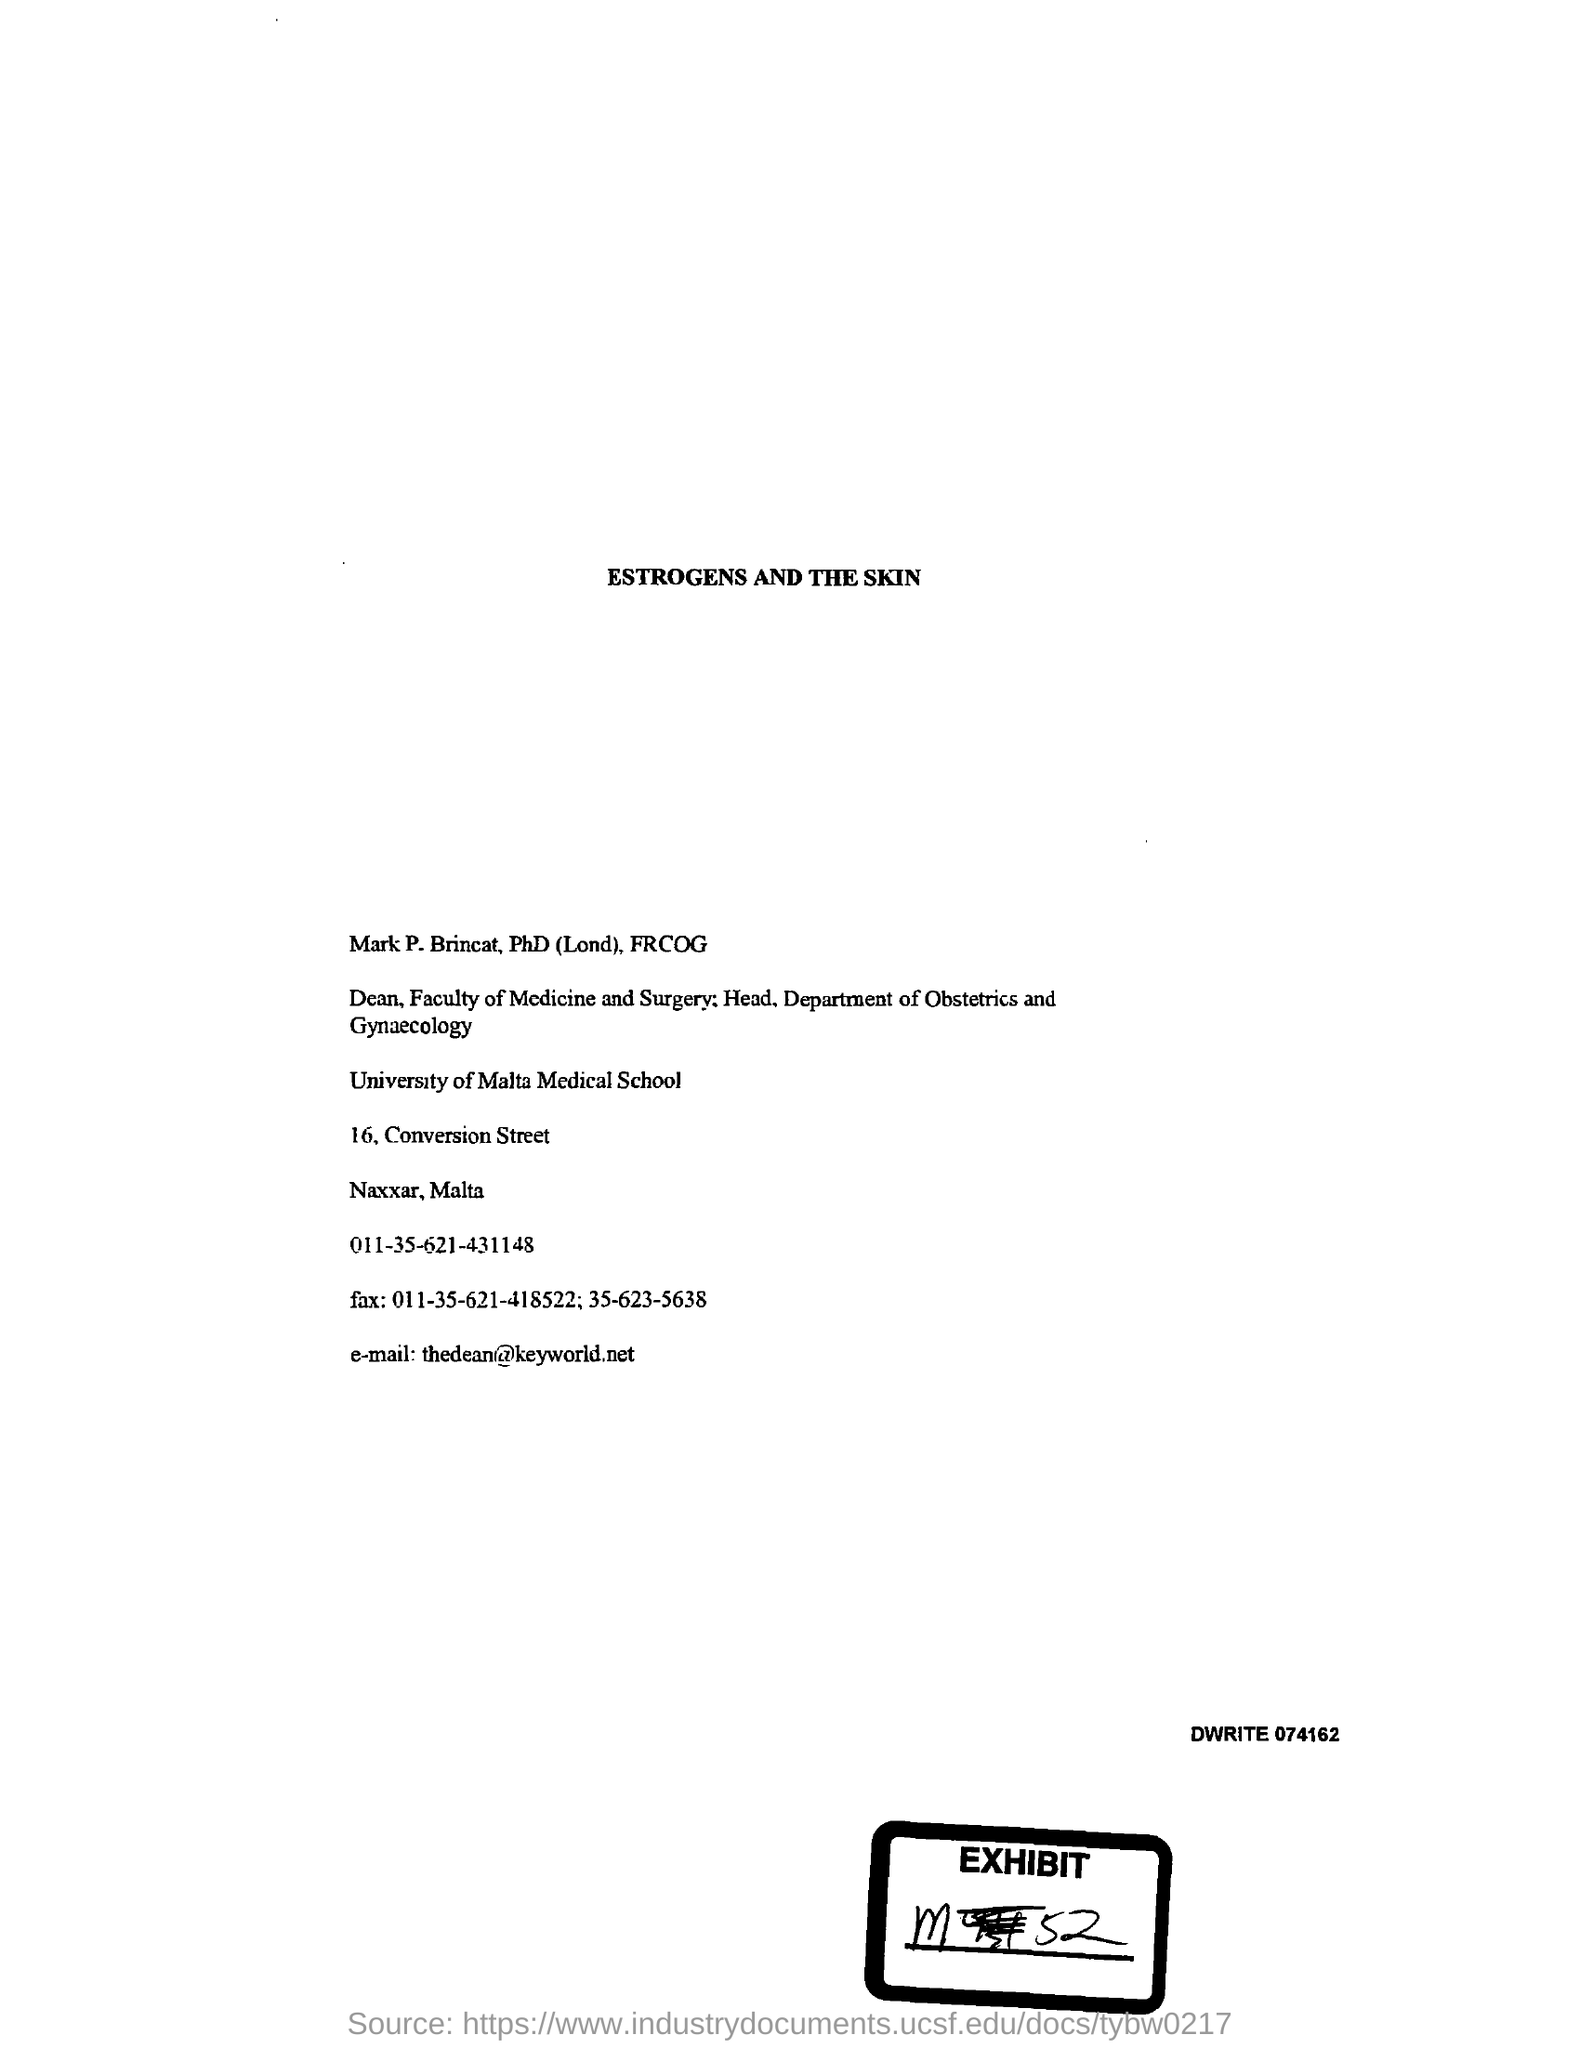What is the Exhibit number?
Offer a terse response. M52. What is the Email id?
Make the answer very short. Thedean@keyworld.net. 